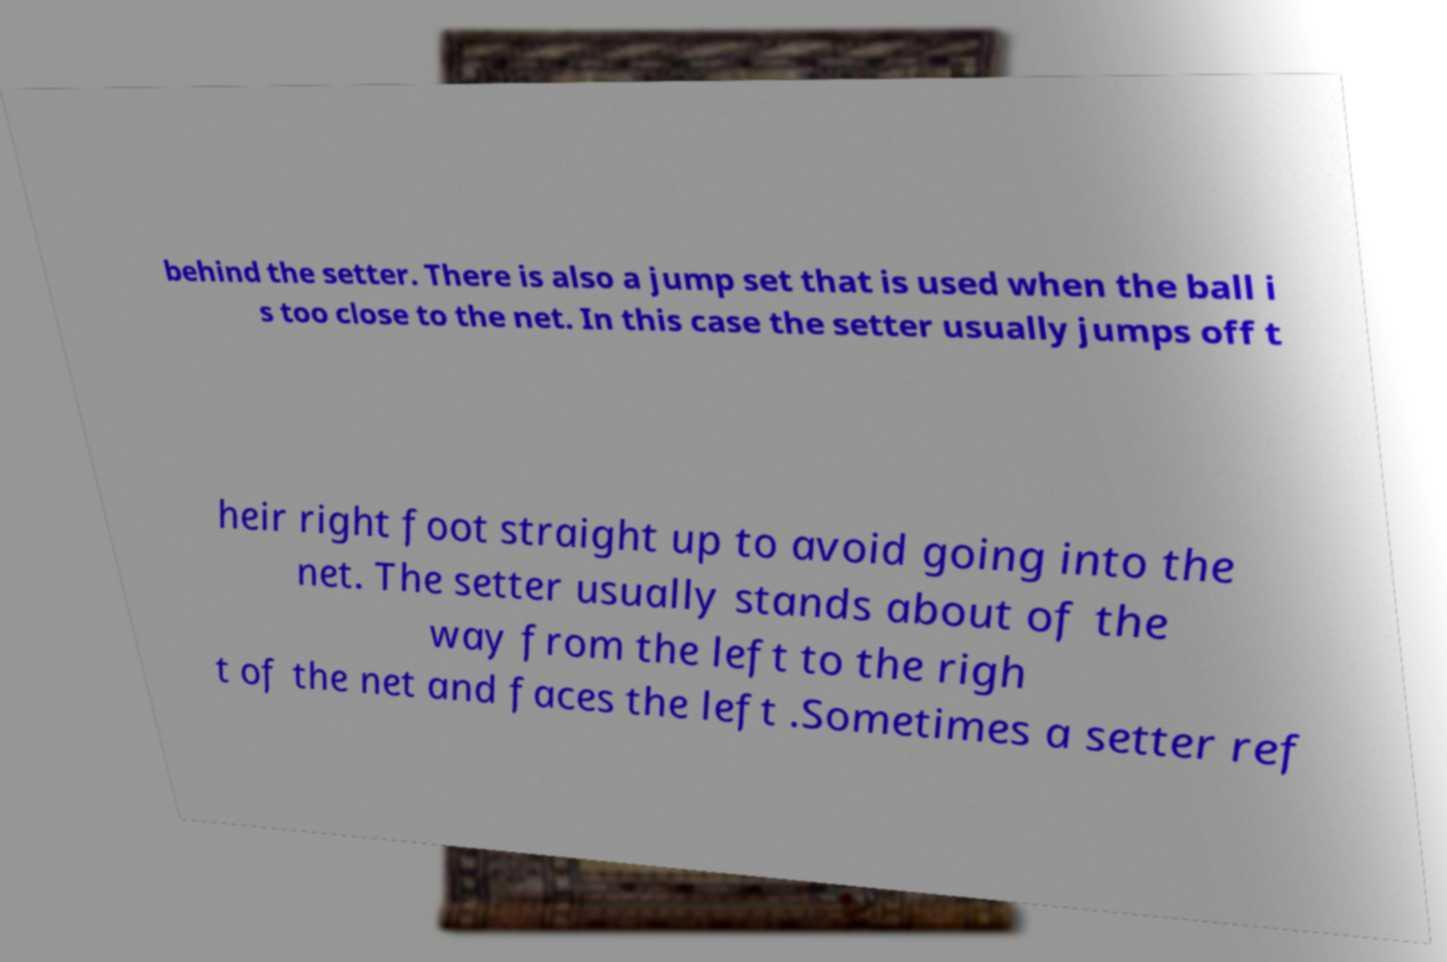There's text embedded in this image that I need extracted. Can you transcribe it verbatim? behind the setter. There is also a jump set that is used when the ball i s too close to the net. In this case the setter usually jumps off t heir right foot straight up to avoid going into the net. The setter usually stands about of the way from the left to the righ t of the net and faces the left .Sometimes a setter ref 